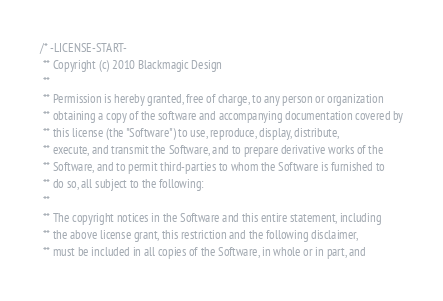Convert code to text. <code><loc_0><loc_0><loc_500><loc_500><_ObjectiveC_>/* -LICENSE-START-
 ** Copyright (c) 2010 Blackmagic Design
 **
 ** Permission is hereby granted, free of charge, to any person or organization
 ** obtaining a copy of the software and accompanying documentation covered by
 ** this license (the "Software") to use, reproduce, display, distribute,
 ** execute, and transmit the Software, and to prepare derivative works of the
 ** Software, and to permit third-parties to whom the Software is furnished to
 ** do so, all subject to the following:
 ** 
 ** The copyright notices in the Software and this entire statement, including
 ** the above license grant, this restriction and the following disclaimer,
 ** must be included in all copies of the Software, in whole or in part, and</code> 